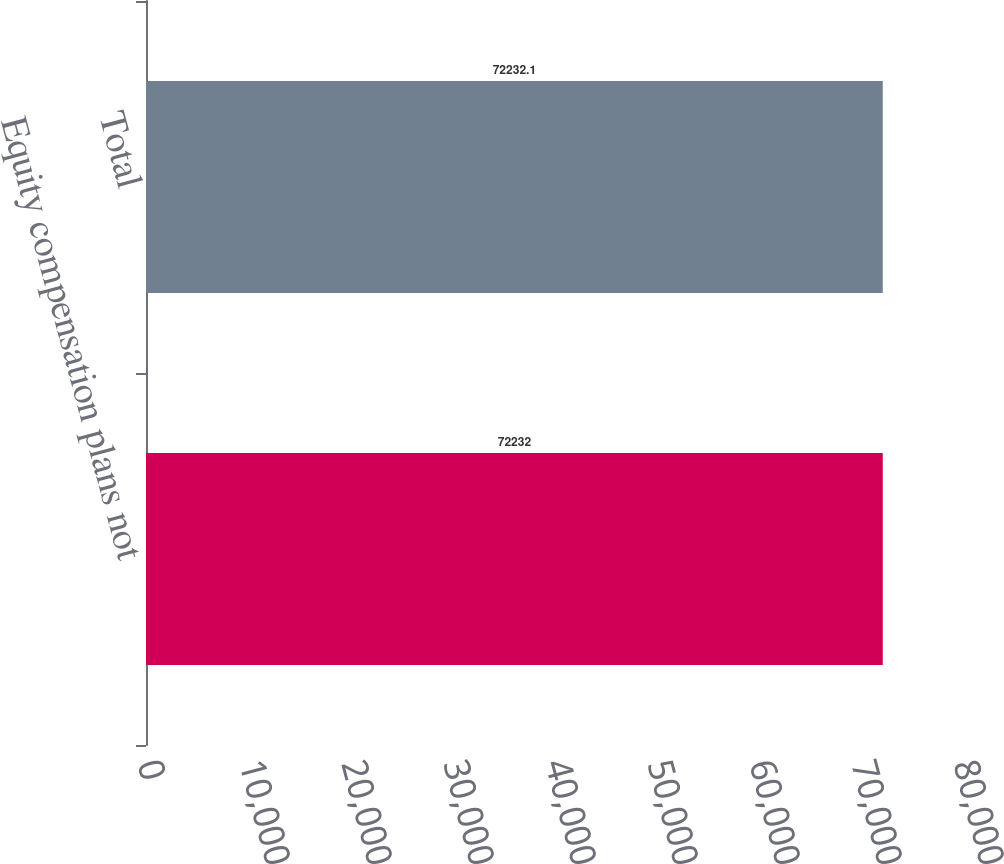Convert chart to OTSL. <chart><loc_0><loc_0><loc_500><loc_500><bar_chart><fcel>Equity compensation plans not<fcel>Total<nl><fcel>72232<fcel>72232.1<nl></chart> 